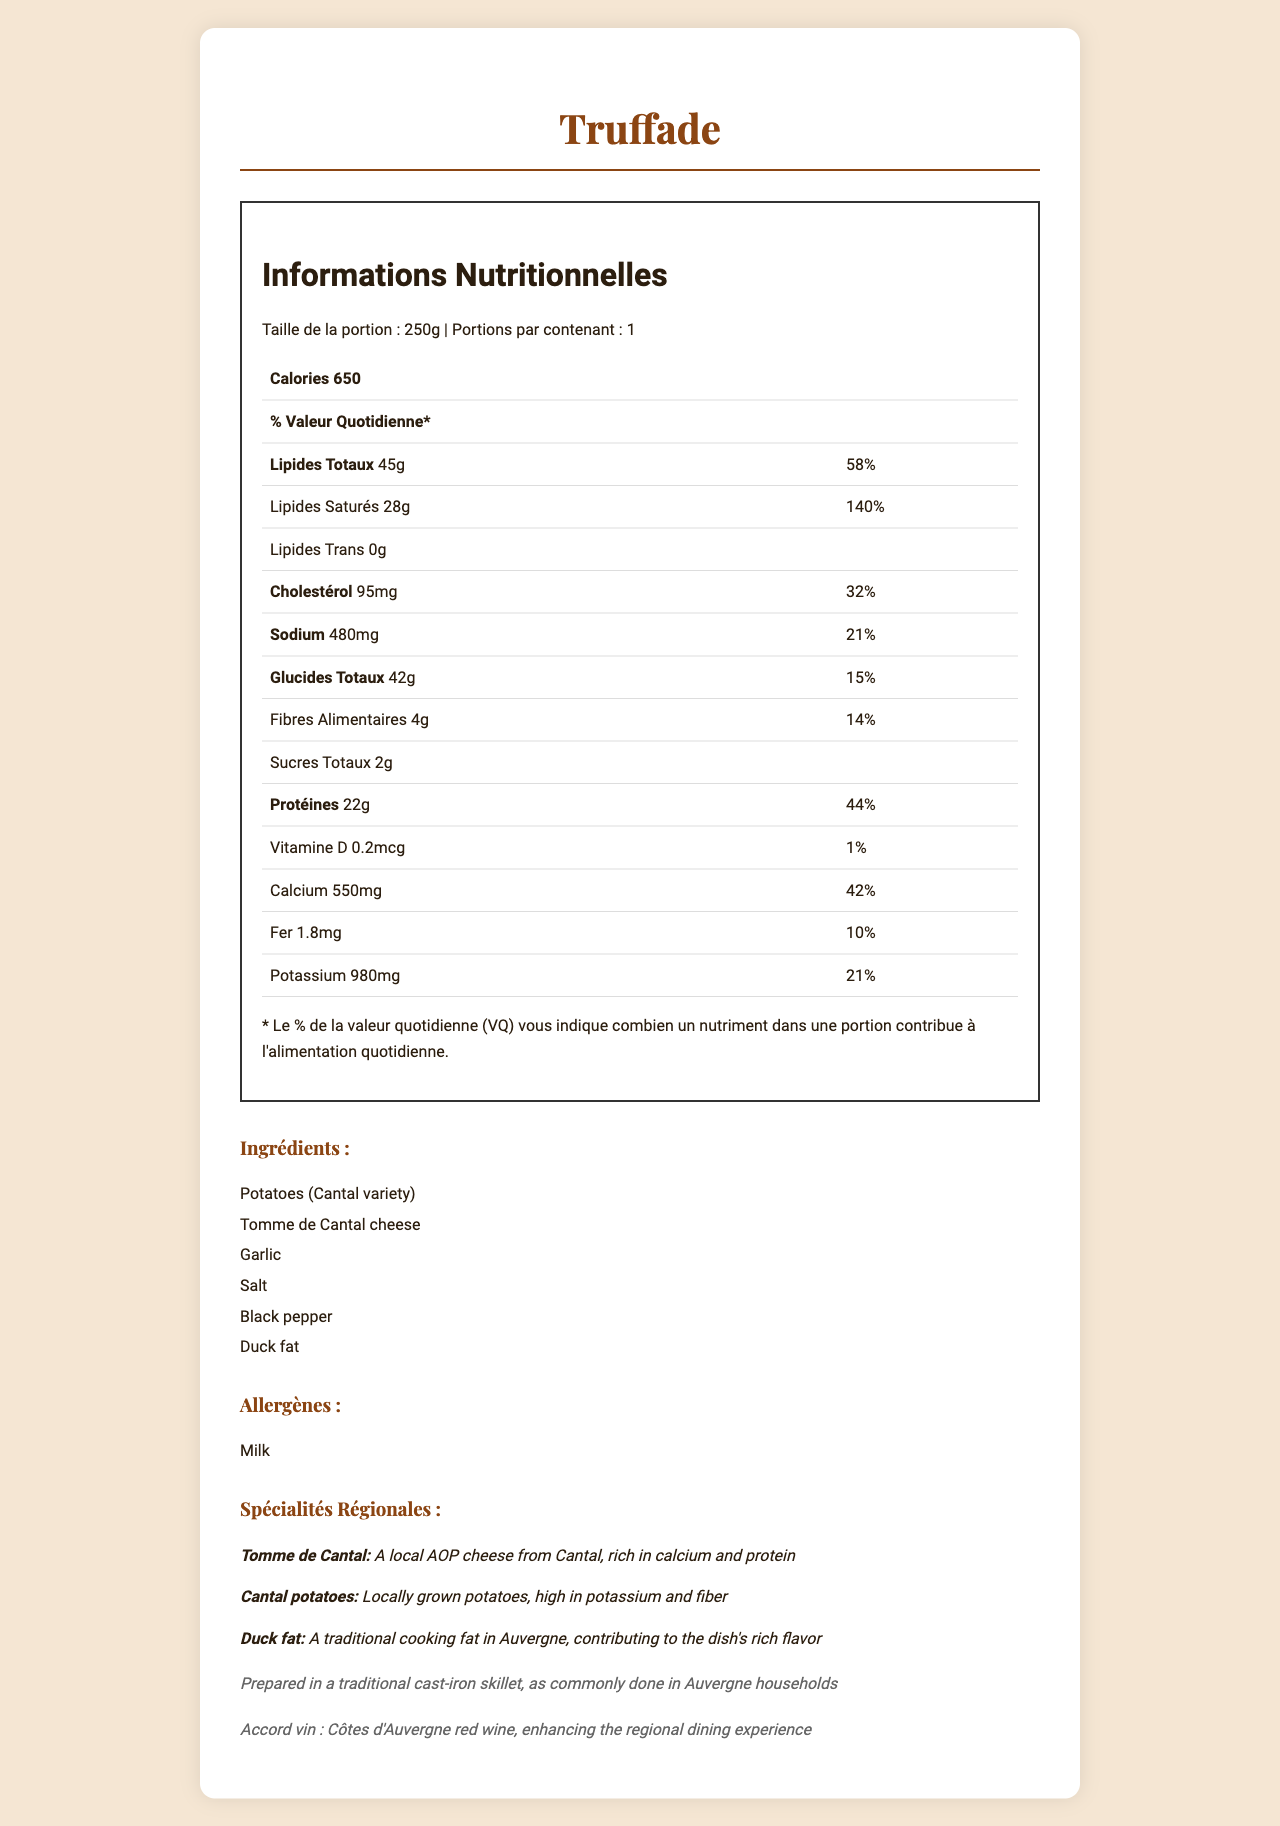what is the serving size for Truffade? The serving size is indicated at the top of the nutrition label as "Taille de la portion : 250g".
Answer: 250g how many calories are in one serving of Truffade? The nutrition facts label states that the dish contains 650 calories per serving.
Answer: 650 what is the total fat content and its daily value percentage? The label shows that Truffade contains 45g of total fat, which is 58% of the daily value.
Answer: 45g, 58% name one key ingredient in Truffade that is also a local specialty? Under the regional highlights, it is mentioned that Tomme de Cantal cheese is a local AOP cheese from Cantal.
Answer: Tomme de Cantal cheese what is the protein content in one serving of Truffade? The nutrition facts label lists 22g of protein for one serving of Truffade.
Answer: 22g what is the percentage of daily value for dietary fiber? The label indicates that dietary fiber is 14% of the daily value.
Answer: 14% how much calcium does Truffade provide per serving? The nutrition label lists the calcium content as 550mg per serving.
Answer: 550mg which ingredient in Truffade contributes to its rich flavor? A. Garlic B. Tomme de Cantal cheese C. Potatoes D. Duck fat The regional highlights section mentions that duck fat is a traditional cooking fat contributing to the dish's rich flavor.
Answer: D. Duck fat how would you describe the allergen content of Truffade? A. Contains nuts B. Contains milk C. Contains gluten D. Contains soy The allergens section specifically lists milk as an allergen.
Answer: B. Contains milk is there any trans fat in Truffade? The nutrition label states that the amount of trans fat is 0g.
Answer: No describe the main regional highlights of the Truffade dish. The regional highlights section emphasizes the use of local ingredients such as Tomme de Cantal cheese and Cantal potatoes, detailing their nutritional benefits. It also mentions the use of duck fat for cooking, aligning with traditional Auvergne culinary practices.
Answer: Truffade is made with Tomme de Cantal cheese, a local AOP cheese from Cantal, and locally grown Cantal potatoes. Both ingredients contribute significantly to the nutritional value, with the cheese being rich in calcium and protein and the potatoes high in potassium and fiber. Duck fat, a traditional cooking fat in Auvergne, gives the dish its rich flavor. what is the sodium content in a single serving of Truffade? The nutrition facts label shows the sodium content as 480mg.
Answer: 480mg can you prepare Truffade in a microwave? The document does not provide any specific information on microwave preparation, only noting the traditional method using a cast-iron skillet.
Answer: Not enough information what is the suggested wine pairing for Truffade? The wine pairing section mentions that Côtes d'Auvergne red wine enhances the regional dining experience.
Answer: Côtes d'Auvergne red wine 